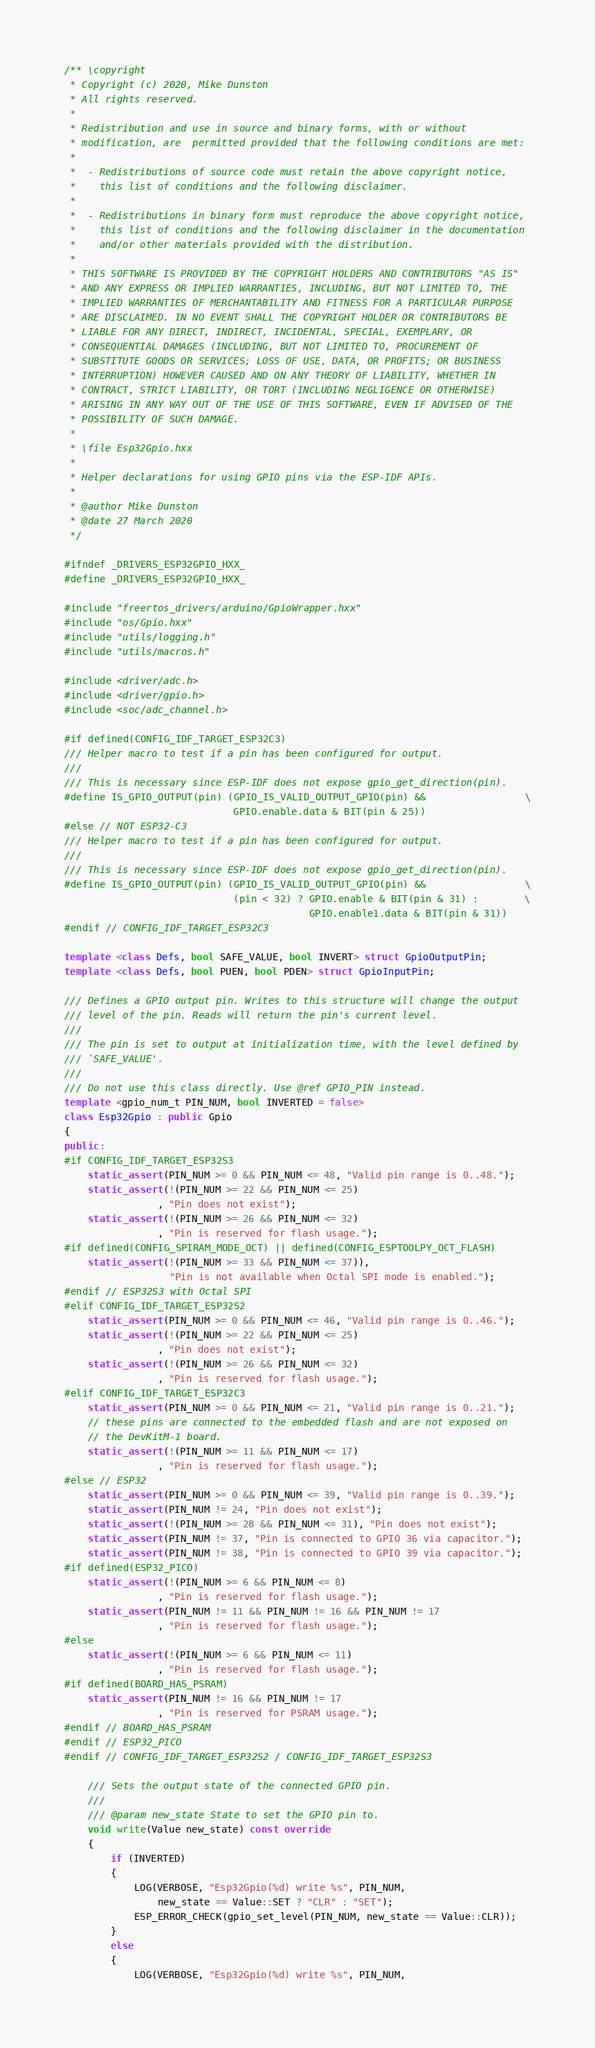Convert code to text. <code><loc_0><loc_0><loc_500><loc_500><_C++_>/** \copyright
 * Copyright (c) 2020, Mike Dunston
 * All rights reserved.
 *
 * Redistribution and use in source and binary forms, with or without
 * modification, are  permitted provided that the following conditions are met:
 *
 *  - Redistributions of source code must retain the above copyright notice,
 *    this list of conditions and the following disclaimer.
 *
 *  - Redistributions in binary form must reproduce the above copyright notice,
 *    this list of conditions and the following disclaimer in the documentation
 *    and/or other materials provided with the distribution.
 *
 * THIS SOFTWARE IS PROVIDED BY THE COPYRIGHT HOLDERS AND CONTRIBUTORS "AS IS"
 * AND ANY EXPRESS OR IMPLIED WARRANTIES, INCLUDING, BUT NOT LIMITED TO, THE
 * IMPLIED WARRANTIES OF MERCHANTABILITY AND FITNESS FOR A PARTICULAR PURPOSE
 * ARE DISCLAIMED. IN NO EVENT SHALL THE COPYRIGHT HOLDER OR CONTRIBUTORS BE
 * LIABLE FOR ANY DIRECT, INDIRECT, INCIDENTAL, SPECIAL, EXEMPLARY, OR
 * CONSEQUENTIAL DAMAGES (INCLUDING, BUT NOT LIMITED TO, PROCUREMENT OF
 * SUBSTITUTE GOODS OR SERVICES; LOSS OF USE, DATA, OR PROFITS; OR BUSINESS
 * INTERRUPTION) HOWEVER CAUSED AND ON ANY THEORY OF LIABILITY, WHETHER IN
 * CONTRACT, STRICT LIABILITY, OR TORT (INCLUDING NEGLIGENCE OR OTHERWISE)
 * ARISING IN ANY WAY OUT OF THE USE OF THIS SOFTWARE, EVEN IF ADVISED OF THE
 * POSSIBILITY OF SUCH DAMAGE.
 *
 * \file Esp32Gpio.hxx
 *
 * Helper declarations for using GPIO pins via the ESP-IDF APIs.
 *
 * @author Mike Dunston
 * @date 27 March 2020
 */

#ifndef _DRIVERS_ESP32GPIO_HXX_
#define _DRIVERS_ESP32GPIO_HXX_

#include "freertos_drivers/arduino/GpioWrapper.hxx"
#include "os/Gpio.hxx"
#include "utils/logging.h"
#include "utils/macros.h"

#include <driver/adc.h>
#include <driver/gpio.h>
#include <soc/adc_channel.h>

#if defined(CONFIG_IDF_TARGET_ESP32C3)
/// Helper macro to test if a pin has been configured for output.
///
/// This is necessary since ESP-IDF does not expose gpio_get_direction(pin).
#define IS_GPIO_OUTPUT(pin) (GPIO_IS_VALID_OUTPUT_GPIO(pin) &&                 \
                             GPIO.enable.data & BIT(pin & 25))
#else // NOT ESP32-C3
/// Helper macro to test if a pin has been configured for output.
///
/// This is necessary since ESP-IDF does not expose gpio_get_direction(pin).
#define IS_GPIO_OUTPUT(pin) (GPIO_IS_VALID_OUTPUT_GPIO(pin) &&                 \
                             (pin < 32) ? GPIO.enable & BIT(pin & 31) :        \
                                          GPIO.enable1.data & BIT(pin & 31))
#endif // CONFIG_IDF_TARGET_ESP32C3

template <class Defs, bool SAFE_VALUE, bool INVERT> struct GpioOutputPin;
template <class Defs, bool PUEN, bool PDEN> struct GpioInputPin;

/// Defines a GPIO output pin. Writes to this structure will change the output
/// level of the pin. Reads will return the pin's current level.
///
/// The pin is set to output at initialization time, with the level defined by
/// `SAFE_VALUE'.
///
/// Do not use this class directly. Use @ref GPIO_PIN instead.
template <gpio_num_t PIN_NUM, bool INVERTED = false>
class Esp32Gpio : public Gpio
{
public:
#if CONFIG_IDF_TARGET_ESP32S3
    static_assert(PIN_NUM >= 0 && PIN_NUM <= 48, "Valid pin range is 0..48.");
    static_assert(!(PIN_NUM >= 22 && PIN_NUM <= 25)
                , "Pin does not exist");
    static_assert(!(PIN_NUM >= 26 && PIN_NUM <= 32)
                , "Pin is reserved for flash usage.");
#if defined(CONFIG_SPIRAM_MODE_OCT) || defined(CONFIG_ESPTOOLPY_OCT_FLASH)
    static_assert(!(PIN_NUM >= 33 && PIN_NUM <= 37)),
                  "Pin is not available when Octal SPI mode is enabled.");
#endif // ESP32S3 with Octal SPI
#elif CONFIG_IDF_TARGET_ESP32S2
    static_assert(PIN_NUM >= 0 && PIN_NUM <= 46, "Valid pin range is 0..46.");
    static_assert(!(PIN_NUM >= 22 && PIN_NUM <= 25)
                , "Pin does not exist");
    static_assert(!(PIN_NUM >= 26 && PIN_NUM <= 32)
                , "Pin is reserved for flash usage.");
#elif CONFIG_IDF_TARGET_ESP32C3
    static_assert(PIN_NUM >= 0 && PIN_NUM <= 21, "Valid pin range is 0..21.");
    // these pins are connected to the embedded flash and are not exposed on
    // the DevKitM-1 board.
    static_assert(!(PIN_NUM >= 11 && PIN_NUM <= 17)
                , "Pin is reserved for flash usage.");
#else // ESP32
    static_assert(PIN_NUM >= 0 && PIN_NUM <= 39, "Valid pin range is 0..39.");
    static_assert(PIN_NUM != 24, "Pin does not exist");
    static_assert(!(PIN_NUM >= 28 && PIN_NUM <= 31), "Pin does not exist");
    static_assert(PIN_NUM != 37, "Pin is connected to GPIO 36 via capacitor.");
    static_assert(PIN_NUM != 38, "Pin is connected to GPIO 39 via capacitor.");
#if defined(ESP32_PICO)
    static_assert(!(PIN_NUM >= 6 && PIN_NUM <= 8)
                , "Pin is reserved for flash usage.");
    static_assert(PIN_NUM != 11 && PIN_NUM != 16 && PIN_NUM != 17
                , "Pin is reserved for flash usage.");
#else
    static_assert(!(PIN_NUM >= 6 && PIN_NUM <= 11)
                , "Pin is reserved for flash usage.");
#if defined(BOARD_HAS_PSRAM)
    static_assert(PIN_NUM != 16 && PIN_NUM != 17
                , "Pin is reserved for PSRAM usage.");
#endif // BOARD_HAS_PSRAM
#endif // ESP32_PICO
#endif // CONFIG_IDF_TARGET_ESP32S2 / CONFIG_IDF_TARGET_ESP32S3

    /// Sets the output state of the connected GPIO pin.
    ///
    /// @param new_state State to set the GPIO pin to.
    void write(Value new_state) const override
    {
        if (INVERTED)
        {
            LOG(VERBOSE, "Esp32Gpio(%d) write %s", PIN_NUM,
                new_state == Value::SET ? "CLR" : "SET");
            ESP_ERROR_CHECK(gpio_set_level(PIN_NUM, new_state == Value::CLR));
        }
        else
        {
            LOG(VERBOSE, "Esp32Gpio(%d) write %s", PIN_NUM,</code> 